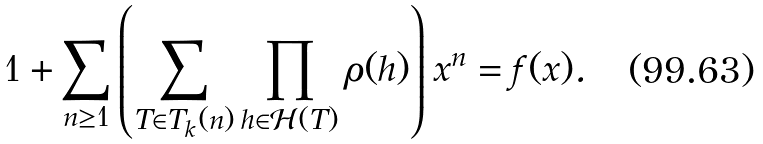<formula> <loc_0><loc_0><loc_500><loc_500>1 + \sum _ { n \geq 1 } \left ( \sum _ { T \in T _ { k } ( n ) } \prod _ { h \in \mathcal { H } ( T ) } \rho ( h ) \right ) x ^ { n } = f ( x ) .</formula> 